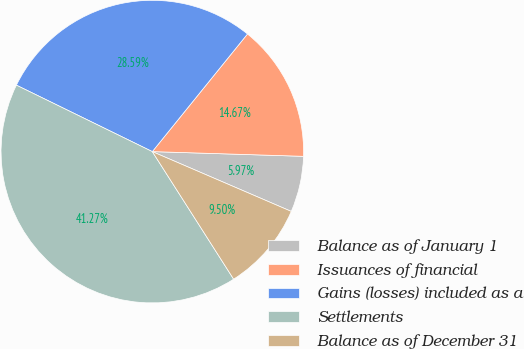Convert chart to OTSL. <chart><loc_0><loc_0><loc_500><loc_500><pie_chart><fcel>Balance as of January 1<fcel>Issuances of financial<fcel>Gains (losses) included as a<fcel>Settlements<fcel>Balance as of December 31<nl><fcel>5.97%<fcel>14.67%<fcel>28.59%<fcel>41.27%<fcel>9.5%<nl></chart> 